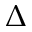Convert formula to latex. <formula><loc_0><loc_0><loc_500><loc_500>\Delta</formula> 